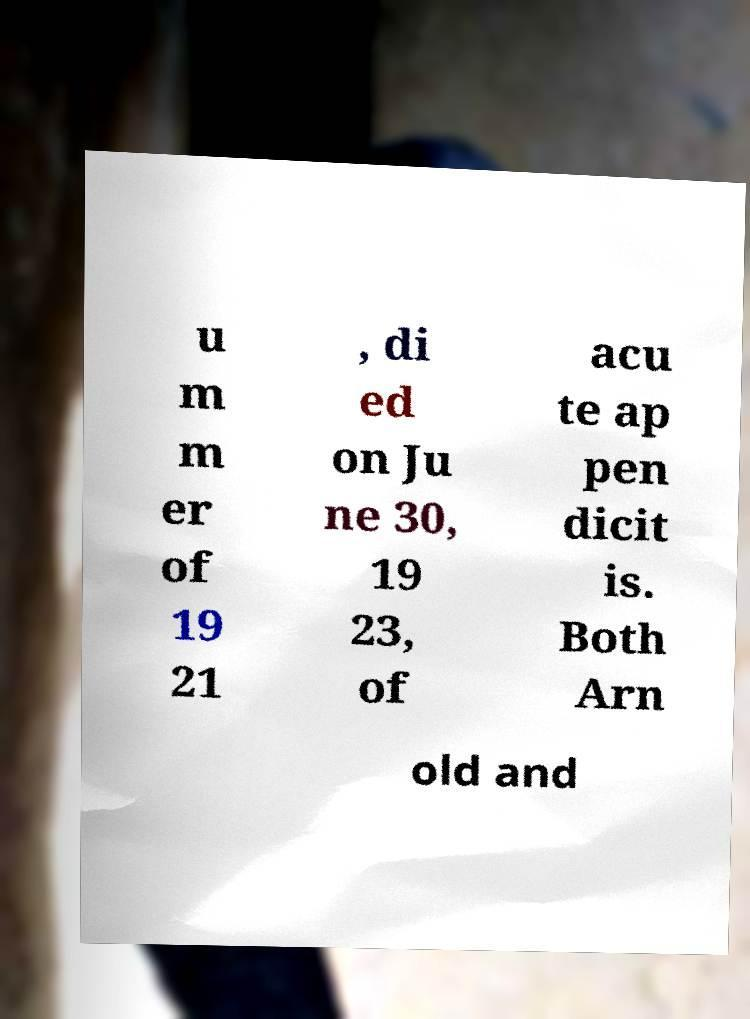I need the written content from this picture converted into text. Can you do that? u m m er of 19 21 , di ed on Ju ne 30, 19 23, of acu te ap pen dicit is. Both Arn old and 